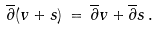Convert formula to latex. <formula><loc_0><loc_0><loc_500><loc_500>\overline { \partial } ( v + s ) \, = \, \overline { \partial } v + \overline { \partial } s \, .</formula> 